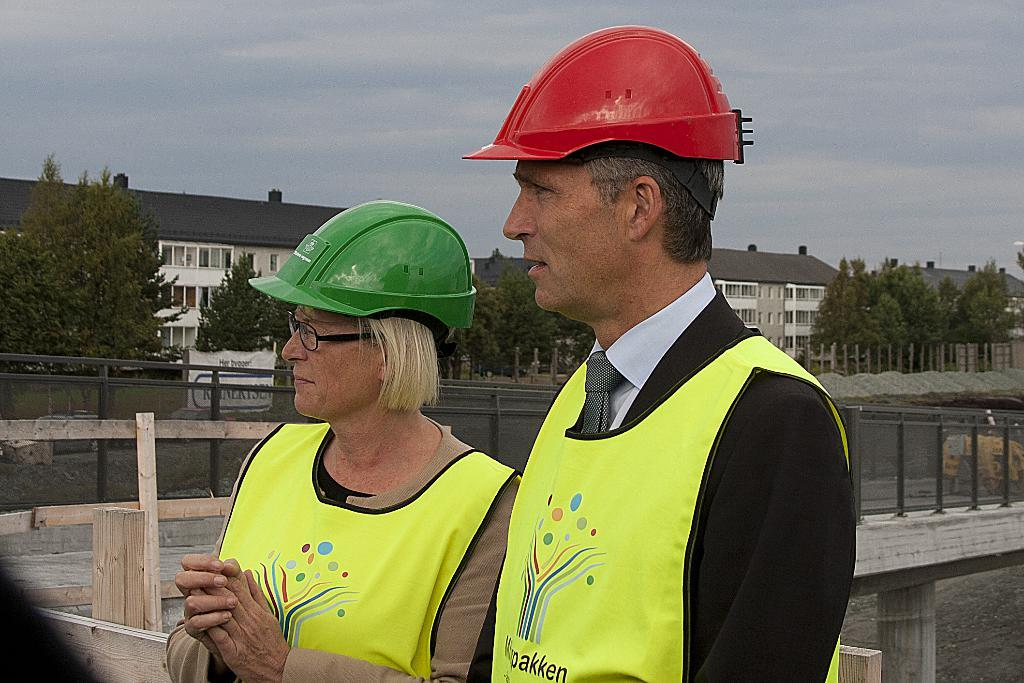How many people are in the image? There are two people in the image. What are the people wearing on their heads? The people are wearing helmets. What can be seen in the image besides the people? There is a fence, a bridge, trees, buildings, a banner, and poles in the image. What is visible in the background of the image? The sky is visible in the background of the image. Can you see a blade being used by the stranger in the image? There is no stranger or blade present in the image. What type of rabbit can be seen hopping near the bridge in the image? There is no rabbit present in the image. 